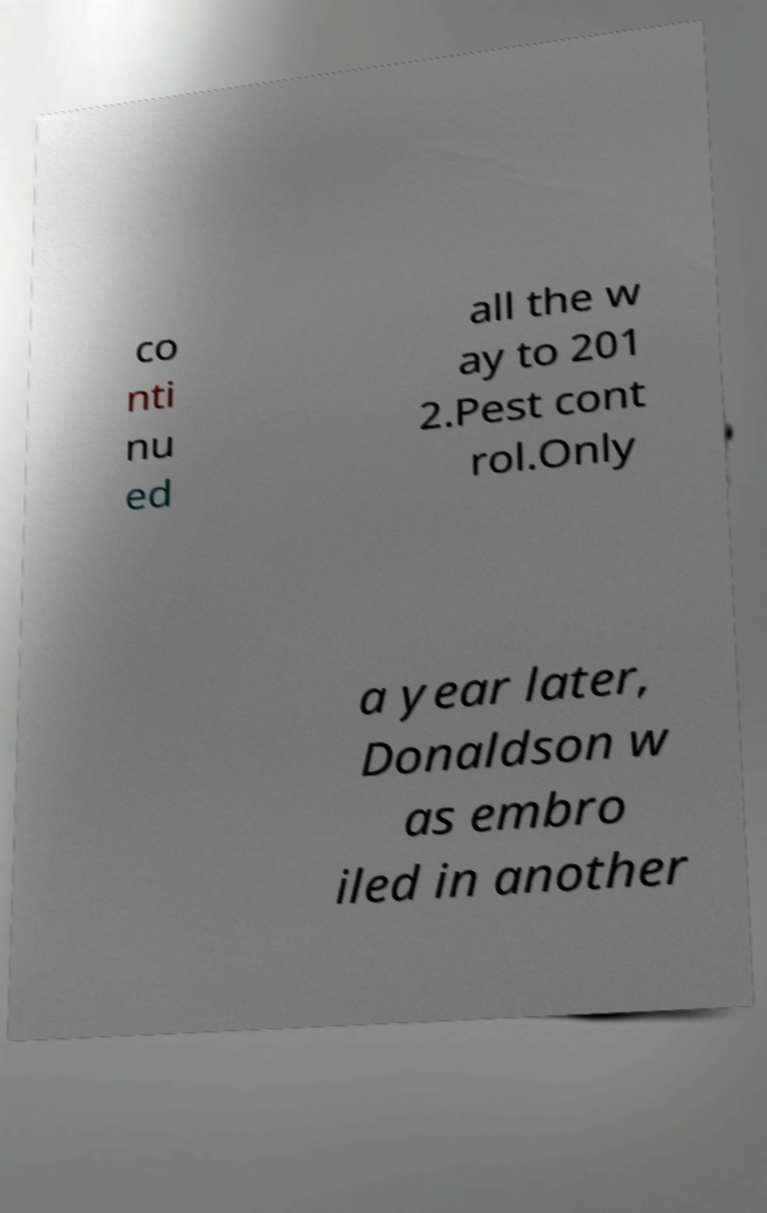Can you read and provide the text displayed in the image?This photo seems to have some interesting text. Can you extract and type it out for me? co nti nu ed all the w ay to 201 2.Pest cont rol.Only a year later, Donaldson w as embro iled in another 